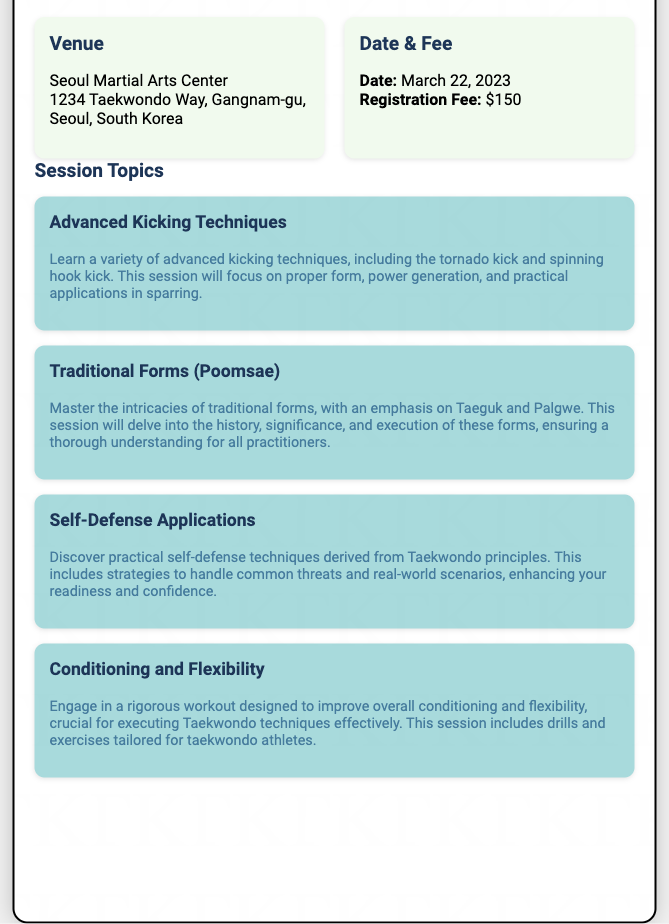What is the title of the seminar? The title of the seminar, as mentioned in the document, is "Exclusive Taekwondo Seminar with Master Instructor."
Answer: Exclusive Taekwondo Seminar with Master Instructor Where is the venue located? The venue section of the document provides the full address of the seminar location in Seoul, which is "Seoul Martial Arts Center, 1234 Taekwondo Way, Gangnam-gu, Seoul, South Korea."
Answer: Seoul Martial Arts Center, 1234 Taekwondo Way, Gangnam-gu, Seoul, South Korea What is the registration fee? The details of the registration fee for attending the seminar is explicitly stated in the document as "$150."
Answer: $150 What date is the seminar scheduled for? The document clearly states the date of the seminar as "March 22, 2023."
Answer: March 22, 2023 Which session focuses on self-defense techniques? The document lists multiple session topics, and the one that focuses on self-defense techniques is titled "Self-Defense Applications."
Answer: Self-Defense Applications How many session topics are mentioned? By examining the document, it is noted that there are four session topics mentioned in total.
Answer: Four Which session emphasizes kicking techniques? The session that emphasizes kicking techniques is titled "Advanced Kicking Techniques," as found in the document.
Answer: Advanced Kicking Techniques What color scheme is used for the venue section? The venue section employs a background color described as "#f1faee," which is a light greenish tint.
Answer: #f1faee 